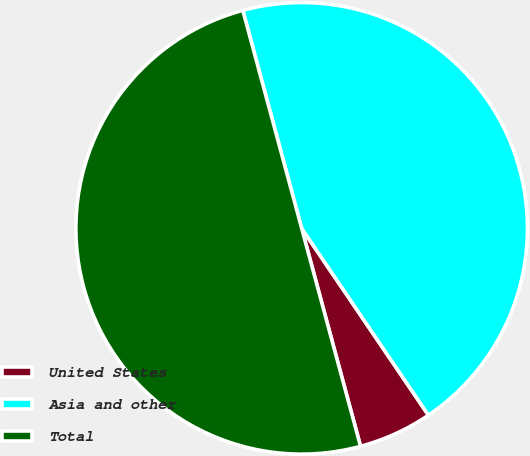Convert chart. <chart><loc_0><loc_0><loc_500><loc_500><pie_chart><fcel>United States<fcel>Asia and other<fcel>Total<nl><fcel>5.29%<fcel>44.71%<fcel>50.0%<nl></chart> 